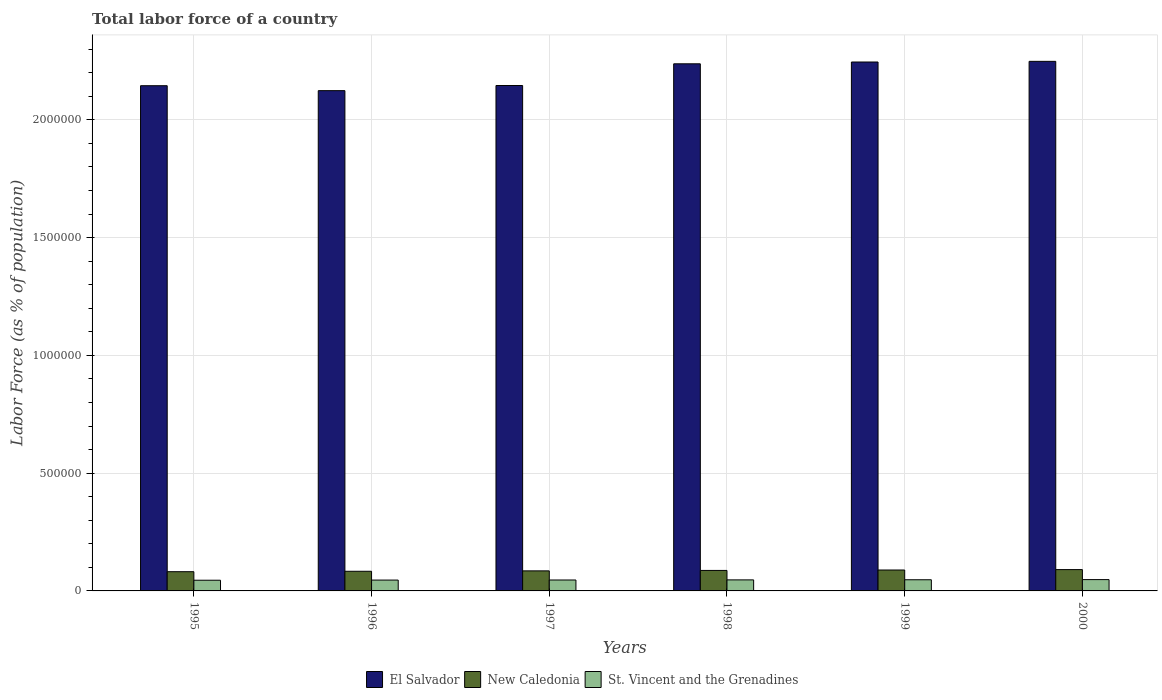How many different coloured bars are there?
Provide a succinct answer. 3. Are the number of bars on each tick of the X-axis equal?
Your answer should be compact. Yes. How many bars are there on the 4th tick from the right?
Your answer should be very brief. 3. What is the percentage of labor force in New Caledonia in 1996?
Your response must be concise. 8.34e+04. Across all years, what is the maximum percentage of labor force in New Caledonia?
Your answer should be very brief. 9.05e+04. Across all years, what is the minimum percentage of labor force in St. Vincent and the Grenadines?
Give a very brief answer. 4.54e+04. In which year was the percentage of labor force in El Salvador maximum?
Your answer should be compact. 2000. What is the total percentage of labor force in New Caledonia in the graph?
Your answer should be very brief. 5.16e+05. What is the difference between the percentage of labor force in El Salvador in 1995 and that in 1997?
Offer a very short reply. -845. What is the difference between the percentage of labor force in El Salvador in 1998 and the percentage of labor force in New Caledonia in 1995?
Your answer should be very brief. 2.16e+06. What is the average percentage of labor force in St. Vincent and the Grenadines per year?
Offer a very short reply. 4.67e+04. In the year 1998, what is the difference between the percentage of labor force in New Caledonia and percentage of labor force in St. Vincent and the Grenadines?
Offer a very short reply. 4.01e+04. In how many years, is the percentage of labor force in New Caledonia greater than 2200000 %?
Your response must be concise. 0. What is the ratio of the percentage of labor force in New Caledonia in 1995 to that in 1999?
Your response must be concise. 0.92. Is the percentage of labor force in El Salvador in 1997 less than that in 1999?
Give a very brief answer. Yes. Is the difference between the percentage of labor force in New Caledonia in 1995 and 1998 greater than the difference between the percentage of labor force in St. Vincent and the Grenadines in 1995 and 1998?
Give a very brief answer. No. What is the difference between the highest and the second highest percentage of labor force in El Salvador?
Your answer should be compact. 2773. What is the difference between the highest and the lowest percentage of labor force in New Caledonia?
Offer a very short reply. 8890. What does the 3rd bar from the left in 1995 represents?
Your answer should be compact. St. Vincent and the Grenadines. What does the 2nd bar from the right in 1996 represents?
Make the answer very short. New Caledonia. Are all the bars in the graph horizontal?
Make the answer very short. No. How many years are there in the graph?
Your response must be concise. 6. What is the difference between two consecutive major ticks on the Y-axis?
Provide a short and direct response. 5.00e+05. How many legend labels are there?
Your response must be concise. 3. How are the legend labels stacked?
Your answer should be very brief. Horizontal. What is the title of the graph?
Your answer should be very brief. Total labor force of a country. What is the label or title of the X-axis?
Provide a short and direct response. Years. What is the label or title of the Y-axis?
Offer a terse response. Labor Force (as % of population). What is the Labor Force (as % of population) of El Salvador in 1995?
Your response must be concise. 2.14e+06. What is the Labor Force (as % of population) in New Caledonia in 1995?
Keep it short and to the point. 8.16e+04. What is the Labor Force (as % of population) in St. Vincent and the Grenadines in 1995?
Provide a succinct answer. 4.54e+04. What is the Labor Force (as % of population) of El Salvador in 1996?
Your response must be concise. 2.12e+06. What is the Labor Force (as % of population) in New Caledonia in 1996?
Ensure brevity in your answer.  8.34e+04. What is the Labor Force (as % of population) in St. Vincent and the Grenadines in 1996?
Make the answer very short. 4.61e+04. What is the Labor Force (as % of population) in El Salvador in 1997?
Offer a terse response. 2.15e+06. What is the Labor Force (as % of population) in New Caledonia in 1997?
Give a very brief answer. 8.51e+04. What is the Labor Force (as % of population) of St. Vincent and the Grenadines in 1997?
Provide a succinct answer. 4.64e+04. What is the Labor Force (as % of population) in El Salvador in 1998?
Ensure brevity in your answer.  2.24e+06. What is the Labor Force (as % of population) of New Caledonia in 1998?
Keep it short and to the point. 8.70e+04. What is the Labor Force (as % of population) in St. Vincent and the Grenadines in 1998?
Make the answer very short. 4.69e+04. What is the Labor Force (as % of population) of El Salvador in 1999?
Make the answer very short. 2.25e+06. What is the Labor Force (as % of population) in New Caledonia in 1999?
Make the answer very short. 8.88e+04. What is the Labor Force (as % of population) in St. Vincent and the Grenadines in 1999?
Ensure brevity in your answer.  4.74e+04. What is the Labor Force (as % of population) of El Salvador in 2000?
Ensure brevity in your answer.  2.25e+06. What is the Labor Force (as % of population) in New Caledonia in 2000?
Offer a terse response. 9.05e+04. What is the Labor Force (as % of population) of St. Vincent and the Grenadines in 2000?
Offer a terse response. 4.81e+04. Across all years, what is the maximum Labor Force (as % of population) of El Salvador?
Your answer should be very brief. 2.25e+06. Across all years, what is the maximum Labor Force (as % of population) in New Caledonia?
Make the answer very short. 9.05e+04. Across all years, what is the maximum Labor Force (as % of population) of St. Vincent and the Grenadines?
Offer a terse response. 4.81e+04. Across all years, what is the minimum Labor Force (as % of population) of El Salvador?
Offer a very short reply. 2.12e+06. Across all years, what is the minimum Labor Force (as % of population) of New Caledonia?
Provide a succinct answer. 8.16e+04. Across all years, what is the minimum Labor Force (as % of population) of St. Vincent and the Grenadines?
Your response must be concise. 4.54e+04. What is the total Labor Force (as % of population) of El Salvador in the graph?
Offer a terse response. 1.31e+07. What is the total Labor Force (as % of population) of New Caledonia in the graph?
Provide a short and direct response. 5.16e+05. What is the total Labor Force (as % of population) in St. Vincent and the Grenadines in the graph?
Offer a terse response. 2.80e+05. What is the difference between the Labor Force (as % of population) in El Salvador in 1995 and that in 1996?
Offer a terse response. 2.10e+04. What is the difference between the Labor Force (as % of population) of New Caledonia in 1995 and that in 1996?
Your response must be concise. -1788. What is the difference between the Labor Force (as % of population) in St. Vincent and the Grenadines in 1995 and that in 1996?
Your answer should be very brief. -701. What is the difference between the Labor Force (as % of population) in El Salvador in 1995 and that in 1997?
Your response must be concise. -845. What is the difference between the Labor Force (as % of population) of New Caledonia in 1995 and that in 1997?
Offer a very short reply. -3479. What is the difference between the Labor Force (as % of population) of St. Vincent and the Grenadines in 1995 and that in 1997?
Offer a very short reply. -1035. What is the difference between the Labor Force (as % of population) in El Salvador in 1995 and that in 1998?
Offer a terse response. -9.30e+04. What is the difference between the Labor Force (as % of population) of New Caledonia in 1995 and that in 1998?
Your response must be concise. -5379. What is the difference between the Labor Force (as % of population) of St. Vincent and the Grenadines in 1995 and that in 1998?
Offer a terse response. -1502. What is the difference between the Labor Force (as % of population) in El Salvador in 1995 and that in 1999?
Give a very brief answer. -1.01e+05. What is the difference between the Labor Force (as % of population) in New Caledonia in 1995 and that in 1999?
Your answer should be very brief. -7140. What is the difference between the Labor Force (as % of population) in St. Vincent and the Grenadines in 1995 and that in 1999?
Your answer should be very brief. -2028. What is the difference between the Labor Force (as % of population) of El Salvador in 1995 and that in 2000?
Give a very brief answer. -1.03e+05. What is the difference between the Labor Force (as % of population) in New Caledonia in 1995 and that in 2000?
Your answer should be very brief. -8890. What is the difference between the Labor Force (as % of population) of St. Vincent and the Grenadines in 1995 and that in 2000?
Provide a succinct answer. -2700. What is the difference between the Labor Force (as % of population) of El Salvador in 1996 and that in 1997?
Provide a succinct answer. -2.18e+04. What is the difference between the Labor Force (as % of population) in New Caledonia in 1996 and that in 1997?
Offer a very short reply. -1691. What is the difference between the Labor Force (as % of population) in St. Vincent and the Grenadines in 1996 and that in 1997?
Your answer should be compact. -334. What is the difference between the Labor Force (as % of population) in El Salvador in 1996 and that in 1998?
Provide a succinct answer. -1.14e+05. What is the difference between the Labor Force (as % of population) of New Caledonia in 1996 and that in 1998?
Your answer should be very brief. -3591. What is the difference between the Labor Force (as % of population) in St. Vincent and the Grenadines in 1996 and that in 1998?
Offer a very short reply. -801. What is the difference between the Labor Force (as % of population) in El Salvador in 1996 and that in 1999?
Your answer should be compact. -1.22e+05. What is the difference between the Labor Force (as % of population) of New Caledonia in 1996 and that in 1999?
Offer a terse response. -5352. What is the difference between the Labor Force (as % of population) of St. Vincent and the Grenadines in 1996 and that in 1999?
Provide a short and direct response. -1327. What is the difference between the Labor Force (as % of population) in El Salvador in 1996 and that in 2000?
Make the answer very short. -1.24e+05. What is the difference between the Labor Force (as % of population) of New Caledonia in 1996 and that in 2000?
Keep it short and to the point. -7102. What is the difference between the Labor Force (as % of population) of St. Vincent and the Grenadines in 1996 and that in 2000?
Keep it short and to the point. -1999. What is the difference between the Labor Force (as % of population) of El Salvador in 1997 and that in 1998?
Provide a short and direct response. -9.22e+04. What is the difference between the Labor Force (as % of population) of New Caledonia in 1997 and that in 1998?
Ensure brevity in your answer.  -1900. What is the difference between the Labor Force (as % of population) in St. Vincent and the Grenadines in 1997 and that in 1998?
Provide a short and direct response. -467. What is the difference between the Labor Force (as % of population) of El Salvador in 1997 and that in 1999?
Keep it short and to the point. -9.98e+04. What is the difference between the Labor Force (as % of population) of New Caledonia in 1997 and that in 1999?
Provide a short and direct response. -3661. What is the difference between the Labor Force (as % of population) in St. Vincent and the Grenadines in 1997 and that in 1999?
Your answer should be compact. -993. What is the difference between the Labor Force (as % of population) in El Salvador in 1997 and that in 2000?
Offer a very short reply. -1.03e+05. What is the difference between the Labor Force (as % of population) of New Caledonia in 1997 and that in 2000?
Provide a succinct answer. -5411. What is the difference between the Labor Force (as % of population) in St. Vincent and the Grenadines in 1997 and that in 2000?
Keep it short and to the point. -1665. What is the difference between the Labor Force (as % of population) of El Salvador in 1998 and that in 1999?
Offer a terse response. -7639. What is the difference between the Labor Force (as % of population) of New Caledonia in 1998 and that in 1999?
Provide a short and direct response. -1761. What is the difference between the Labor Force (as % of population) of St. Vincent and the Grenadines in 1998 and that in 1999?
Your answer should be very brief. -526. What is the difference between the Labor Force (as % of population) of El Salvador in 1998 and that in 2000?
Keep it short and to the point. -1.04e+04. What is the difference between the Labor Force (as % of population) of New Caledonia in 1998 and that in 2000?
Your answer should be very brief. -3511. What is the difference between the Labor Force (as % of population) of St. Vincent and the Grenadines in 1998 and that in 2000?
Give a very brief answer. -1198. What is the difference between the Labor Force (as % of population) of El Salvador in 1999 and that in 2000?
Offer a terse response. -2773. What is the difference between the Labor Force (as % of population) in New Caledonia in 1999 and that in 2000?
Ensure brevity in your answer.  -1750. What is the difference between the Labor Force (as % of population) in St. Vincent and the Grenadines in 1999 and that in 2000?
Keep it short and to the point. -672. What is the difference between the Labor Force (as % of population) of El Salvador in 1995 and the Labor Force (as % of population) of New Caledonia in 1996?
Your answer should be very brief. 2.06e+06. What is the difference between the Labor Force (as % of population) in El Salvador in 1995 and the Labor Force (as % of population) in St. Vincent and the Grenadines in 1996?
Offer a terse response. 2.10e+06. What is the difference between the Labor Force (as % of population) in New Caledonia in 1995 and the Labor Force (as % of population) in St. Vincent and the Grenadines in 1996?
Offer a very short reply. 3.56e+04. What is the difference between the Labor Force (as % of population) of El Salvador in 1995 and the Labor Force (as % of population) of New Caledonia in 1997?
Give a very brief answer. 2.06e+06. What is the difference between the Labor Force (as % of population) of El Salvador in 1995 and the Labor Force (as % of population) of St. Vincent and the Grenadines in 1997?
Make the answer very short. 2.10e+06. What is the difference between the Labor Force (as % of population) of New Caledonia in 1995 and the Labor Force (as % of population) of St. Vincent and the Grenadines in 1997?
Make the answer very short. 3.52e+04. What is the difference between the Labor Force (as % of population) of El Salvador in 1995 and the Labor Force (as % of population) of New Caledonia in 1998?
Offer a very short reply. 2.06e+06. What is the difference between the Labor Force (as % of population) of El Salvador in 1995 and the Labor Force (as % of population) of St. Vincent and the Grenadines in 1998?
Offer a very short reply. 2.10e+06. What is the difference between the Labor Force (as % of population) of New Caledonia in 1995 and the Labor Force (as % of population) of St. Vincent and the Grenadines in 1998?
Make the answer very short. 3.48e+04. What is the difference between the Labor Force (as % of population) in El Salvador in 1995 and the Labor Force (as % of population) in New Caledonia in 1999?
Ensure brevity in your answer.  2.06e+06. What is the difference between the Labor Force (as % of population) of El Salvador in 1995 and the Labor Force (as % of population) of St. Vincent and the Grenadines in 1999?
Your answer should be very brief. 2.10e+06. What is the difference between the Labor Force (as % of population) of New Caledonia in 1995 and the Labor Force (as % of population) of St. Vincent and the Grenadines in 1999?
Offer a very short reply. 3.42e+04. What is the difference between the Labor Force (as % of population) of El Salvador in 1995 and the Labor Force (as % of population) of New Caledonia in 2000?
Ensure brevity in your answer.  2.05e+06. What is the difference between the Labor Force (as % of population) in El Salvador in 1995 and the Labor Force (as % of population) in St. Vincent and the Grenadines in 2000?
Offer a very short reply. 2.10e+06. What is the difference between the Labor Force (as % of population) of New Caledonia in 1995 and the Labor Force (as % of population) of St. Vincent and the Grenadines in 2000?
Keep it short and to the point. 3.36e+04. What is the difference between the Labor Force (as % of population) of El Salvador in 1996 and the Labor Force (as % of population) of New Caledonia in 1997?
Provide a succinct answer. 2.04e+06. What is the difference between the Labor Force (as % of population) of El Salvador in 1996 and the Labor Force (as % of population) of St. Vincent and the Grenadines in 1997?
Provide a succinct answer. 2.08e+06. What is the difference between the Labor Force (as % of population) in New Caledonia in 1996 and the Labor Force (as % of population) in St. Vincent and the Grenadines in 1997?
Give a very brief answer. 3.70e+04. What is the difference between the Labor Force (as % of population) in El Salvador in 1996 and the Labor Force (as % of population) in New Caledonia in 1998?
Your response must be concise. 2.04e+06. What is the difference between the Labor Force (as % of population) of El Salvador in 1996 and the Labor Force (as % of population) of St. Vincent and the Grenadines in 1998?
Ensure brevity in your answer.  2.08e+06. What is the difference between the Labor Force (as % of population) of New Caledonia in 1996 and the Labor Force (as % of population) of St. Vincent and the Grenadines in 1998?
Your answer should be very brief. 3.65e+04. What is the difference between the Labor Force (as % of population) in El Salvador in 1996 and the Labor Force (as % of population) in New Caledonia in 1999?
Provide a short and direct response. 2.03e+06. What is the difference between the Labor Force (as % of population) of El Salvador in 1996 and the Labor Force (as % of population) of St. Vincent and the Grenadines in 1999?
Your answer should be very brief. 2.08e+06. What is the difference between the Labor Force (as % of population) in New Caledonia in 1996 and the Labor Force (as % of population) in St. Vincent and the Grenadines in 1999?
Ensure brevity in your answer.  3.60e+04. What is the difference between the Labor Force (as % of population) of El Salvador in 1996 and the Labor Force (as % of population) of New Caledonia in 2000?
Your answer should be very brief. 2.03e+06. What is the difference between the Labor Force (as % of population) of El Salvador in 1996 and the Labor Force (as % of population) of St. Vincent and the Grenadines in 2000?
Provide a short and direct response. 2.08e+06. What is the difference between the Labor Force (as % of population) in New Caledonia in 1996 and the Labor Force (as % of population) in St. Vincent and the Grenadines in 2000?
Keep it short and to the point. 3.53e+04. What is the difference between the Labor Force (as % of population) of El Salvador in 1997 and the Labor Force (as % of population) of New Caledonia in 1998?
Provide a succinct answer. 2.06e+06. What is the difference between the Labor Force (as % of population) of El Salvador in 1997 and the Labor Force (as % of population) of St. Vincent and the Grenadines in 1998?
Ensure brevity in your answer.  2.10e+06. What is the difference between the Labor Force (as % of population) in New Caledonia in 1997 and the Labor Force (as % of population) in St. Vincent and the Grenadines in 1998?
Offer a very short reply. 3.82e+04. What is the difference between the Labor Force (as % of population) in El Salvador in 1997 and the Labor Force (as % of population) in New Caledonia in 1999?
Provide a short and direct response. 2.06e+06. What is the difference between the Labor Force (as % of population) in El Salvador in 1997 and the Labor Force (as % of population) in St. Vincent and the Grenadines in 1999?
Provide a succinct answer. 2.10e+06. What is the difference between the Labor Force (as % of population) in New Caledonia in 1997 and the Labor Force (as % of population) in St. Vincent and the Grenadines in 1999?
Provide a succinct answer. 3.77e+04. What is the difference between the Labor Force (as % of population) of El Salvador in 1997 and the Labor Force (as % of population) of New Caledonia in 2000?
Offer a terse response. 2.05e+06. What is the difference between the Labor Force (as % of population) of El Salvador in 1997 and the Labor Force (as % of population) of St. Vincent and the Grenadines in 2000?
Ensure brevity in your answer.  2.10e+06. What is the difference between the Labor Force (as % of population) of New Caledonia in 1997 and the Labor Force (as % of population) of St. Vincent and the Grenadines in 2000?
Offer a very short reply. 3.70e+04. What is the difference between the Labor Force (as % of population) of El Salvador in 1998 and the Labor Force (as % of population) of New Caledonia in 1999?
Offer a terse response. 2.15e+06. What is the difference between the Labor Force (as % of population) in El Salvador in 1998 and the Labor Force (as % of population) in St. Vincent and the Grenadines in 1999?
Keep it short and to the point. 2.19e+06. What is the difference between the Labor Force (as % of population) in New Caledonia in 1998 and the Labor Force (as % of population) in St. Vincent and the Grenadines in 1999?
Make the answer very short. 3.96e+04. What is the difference between the Labor Force (as % of population) of El Salvador in 1998 and the Labor Force (as % of population) of New Caledonia in 2000?
Keep it short and to the point. 2.15e+06. What is the difference between the Labor Force (as % of population) in El Salvador in 1998 and the Labor Force (as % of population) in St. Vincent and the Grenadines in 2000?
Provide a short and direct response. 2.19e+06. What is the difference between the Labor Force (as % of population) in New Caledonia in 1998 and the Labor Force (as % of population) in St. Vincent and the Grenadines in 2000?
Your response must be concise. 3.89e+04. What is the difference between the Labor Force (as % of population) of El Salvador in 1999 and the Labor Force (as % of population) of New Caledonia in 2000?
Provide a succinct answer. 2.15e+06. What is the difference between the Labor Force (as % of population) of El Salvador in 1999 and the Labor Force (as % of population) of St. Vincent and the Grenadines in 2000?
Ensure brevity in your answer.  2.20e+06. What is the difference between the Labor Force (as % of population) of New Caledonia in 1999 and the Labor Force (as % of population) of St. Vincent and the Grenadines in 2000?
Make the answer very short. 4.07e+04. What is the average Labor Force (as % of population) in El Salvador per year?
Offer a very short reply. 2.19e+06. What is the average Labor Force (as % of population) in New Caledonia per year?
Provide a succinct answer. 8.61e+04. What is the average Labor Force (as % of population) of St. Vincent and the Grenadines per year?
Provide a succinct answer. 4.67e+04. In the year 1995, what is the difference between the Labor Force (as % of population) in El Salvador and Labor Force (as % of population) in New Caledonia?
Provide a short and direct response. 2.06e+06. In the year 1995, what is the difference between the Labor Force (as % of population) of El Salvador and Labor Force (as % of population) of St. Vincent and the Grenadines?
Your answer should be very brief. 2.10e+06. In the year 1995, what is the difference between the Labor Force (as % of population) of New Caledonia and Labor Force (as % of population) of St. Vincent and the Grenadines?
Keep it short and to the point. 3.63e+04. In the year 1996, what is the difference between the Labor Force (as % of population) in El Salvador and Labor Force (as % of population) in New Caledonia?
Your response must be concise. 2.04e+06. In the year 1996, what is the difference between the Labor Force (as % of population) in El Salvador and Labor Force (as % of population) in St. Vincent and the Grenadines?
Keep it short and to the point. 2.08e+06. In the year 1996, what is the difference between the Labor Force (as % of population) of New Caledonia and Labor Force (as % of population) of St. Vincent and the Grenadines?
Provide a succinct answer. 3.73e+04. In the year 1997, what is the difference between the Labor Force (as % of population) of El Salvador and Labor Force (as % of population) of New Caledonia?
Offer a very short reply. 2.06e+06. In the year 1997, what is the difference between the Labor Force (as % of population) of El Salvador and Labor Force (as % of population) of St. Vincent and the Grenadines?
Provide a short and direct response. 2.10e+06. In the year 1997, what is the difference between the Labor Force (as % of population) of New Caledonia and Labor Force (as % of population) of St. Vincent and the Grenadines?
Offer a terse response. 3.87e+04. In the year 1998, what is the difference between the Labor Force (as % of population) of El Salvador and Labor Force (as % of population) of New Caledonia?
Your response must be concise. 2.15e+06. In the year 1998, what is the difference between the Labor Force (as % of population) in El Salvador and Labor Force (as % of population) in St. Vincent and the Grenadines?
Provide a short and direct response. 2.19e+06. In the year 1998, what is the difference between the Labor Force (as % of population) in New Caledonia and Labor Force (as % of population) in St. Vincent and the Grenadines?
Your response must be concise. 4.01e+04. In the year 1999, what is the difference between the Labor Force (as % of population) in El Salvador and Labor Force (as % of population) in New Caledonia?
Offer a terse response. 2.16e+06. In the year 1999, what is the difference between the Labor Force (as % of population) of El Salvador and Labor Force (as % of population) of St. Vincent and the Grenadines?
Offer a terse response. 2.20e+06. In the year 1999, what is the difference between the Labor Force (as % of population) of New Caledonia and Labor Force (as % of population) of St. Vincent and the Grenadines?
Offer a terse response. 4.14e+04. In the year 2000, what is the difference between the Labor Force (as % of population) in El Salvador and Labor Force (as % of population) in New Caledonia?
Your answer should be very brief. 2.16e+06. In the year 2000, what is the difference between the Labor Force (as % of population) in El Salvador and Labor Force (as % of population) in St. Vincent and the Grenadines?
Make the answer very short. 2.20e+06. In the year 2000, what is the difference between the Labor Force (as % of population) of New Caledonia and Labor Force (as % of population) of St. Vincent and the Grenadines?
Make the answer very short. 4.24e+04. What is the ratio of the Labor Force (as % of population) in El Salvador in 1995 to that in 1996?
Give a very brief answer. 1.01. What is the ratio of the Labor Force (as % of population) of New Caledonia in 1995 to that in 1996?
Keep it short and to the point. 0.98. What is the ratio of the Labor Force (as % of population) in St. Vincent and the Grenadines in 1995 to that in 1996?
Your answer should be compact. 0.98. What is the ratio of the Labor Force (as % of population) in El Salvador in 1995 to that in 1997?
Offer a very short reply. 1. What is the ratio of the Labor Force (as % of population) in New Caledonia in 1995 to that in 1997?
Make the answer very short. 0.96. What is the ratio of the Labor Force (as % of population) in St. Vincent and the Grenadines in 1995 to that in 1997?
Make the answer very short. 0.98. What is the ratio of the Labor Force (as % of population) in El Salvador in 1995 to that in 1998?
Offer a terse response. 0.96. What is the ratio of the Labor Force (as % of population) of New Caledonia in 1995 to that in 1998?
Offer a terse response. 0.94. What is the ratio of the Labor Force (as % of population) in El Salvador in 1995 to that in 1999?
Your answer should be compact. 0.96. What is the ratio of the Labor Force (as % of population) of New Caledonia in 1995 to that in 1999?
Your answer should be very brief. 0.92. What is the ratio of the Labor Force (as % of population) in St. Vincent and the Grenadines in 1995 to that in 1999?
Your response must be concise. 0.96. What is the ratio of the Labor Force (as % of population) in El Salvador in 1995 to that in 2000?
Ensure brevity in your answer.  0.95. What is the ratio of the Labor Force (as % of population) of New Caledonia in 1995 to that in 2000?
Make the answer very short. 0.9. What is the ratio of the Labor Force (as % of population) of St. Vincent and the Grenadines in 1995 to that in 2000?
Your answer should be very brief. 0.94. What is the ratio of the Labor Force (as % of population) of New Caledonia in 1996 to that in 1997?
Offer a very short reply. 0.98. What is the ratio of the Labor Force (as % of population) of St. Vincent and the Grenadines in 1996 to that in 1997?
Your answer should be compact. 0.99. What is the ratio of the Labor Force (as % of population) in El Salvador in 1996 to that in 1998?
Your response must be concise. 0.95. What is the ratio of the Labor Force (as % of population) of New Caledonia in 1996 to that in 1998?
Make the answer very short. 0.96. What is the ratio of the Labor Force (as % of population) in St. Vincent and the Grenadines in 1996 to that in 1998?
Your answer should be very brief. 0.98. What is the ratio of the Labor Force (as % of population) in El Salvador in 1996 to that in 1999?
Provide a short and direct response. 0.95. What is the ratio of the Labor Force (as % of population) of New Caledonia in 1996 to that in 1999?
Give a very brief answer. 0.94. What is the ratio of the Labor Force (as % of population) in St. Vincent and the Grenadines in 1996 to that in 1999?
Your answer should be very brief. 0.97. What is the ratio of the Labor Force (as % of population) of El Salvador in 1996 to that in 2000?
Offer a terse response. 0.94. What is the ratio of the Labor Force (as % of population) of New Caledonia in 1996 to that in 2000?
Ensure brevity in your answer.  0.92. What is the ratio of the Labor Force (as % of population) in St. Vincent and the Grenadines in 1996 to that in 2000?
Offer a terse response. 0.96. What is the ratio of the Labor Force (as % of population) of El Salvador in 1997 to that in 1998?
Provide a short and direct response. 0.96. What is the ratio of the Labor Force (as % of population) of New Caledonia in 1997 to that in 1998?
Your response must be concise. 0.98. What is the ratio of the Labor Force (as % of population) in St. Vincent and the Grenadines in 1997 to that in 1998?
Ensure brevity in your answer.  0.99. What is the ratio of the Labor Force (as % of population) in El Salvador in 1997 to that in 1999?
Offer a terse response. 0.96. What is the ratio of the Labor Force (as % of population) in New Caledonia in 1997 to that in 1999?
Provide a short and direct response. 0.96. What is the ratio of the Labor Force (as % of population) of St. Vincent and the Grenadines in 1997 to that in 1999?
Make the answer very short. 0.98. What is the ratio of the Labor Force (as % of population) in El Salvador in 1997 to that in 2000?
Your answer should be compact. 0.95. What is the ratio of the Labor Force (as % of population) of New Caledonia in 1997 to that in 2000?
Provide a short and direct response. 0.94. What is the ratio of the Labor Force (as % of population) of St. Vincent and the Grenadines in 1997 to that in 2000?
Offer a very short reply. 0.97. What is the ratio of the Labor Force (as % of population) of New Caledonia in 1998 to that in 1999?
Your answer should be compact. 0.98. What is the ratio of the Labor Force (as % of population) of St. Vincent and the Grenadines in 1998 to that in 1999?
Provide a succinct answer. 0.99. What is the ratio of the Labor Force (as % of population) of El Salvador in 1998 to that in 2000?
Offer a very short reply. 1. What is the ratio of the Labor Force (as % of population) in New Caledonia in 1998 to that in 2000?
Make the answer very short. 0.96. What is the ratio of the Labor Force (as % of population) of St. Vincent and the Grenadines in 1998 to that in 2000?
Provide a succinct answer. 0.98. What is the ratio of the Labor Force (as % of population) in El Salvador in 1999 to that in 2000?
Your response must be concise. 1. What is the ratio of the Labor Force (as % of population) in New Caledonia in 1999 to that in 2000?
Your response must be concise. 0.98. What is the ratio of the Labor Force (as % of population) in St. Vincent and the Grenadines in 1999 to that in 2000?
Your response must be concise. 0.99. What is the difference between the highest and the second highest Labor Force (as % of population) in El Salvador?
Keep it short and to the point. 2773. What is the difference between the highest and the second highest Labor Force (as % of population) in New Caledonia?
Your response must be concise. 1750. What is the difference between the highest and the second highest Labor Force (as % of population) of St. Vincent and the Grenadines?
Provide a short and direct response. 672. What is the difference between the highest and the lowest Labor Force (as % of population) of El Salvador?
Make the answer very short. 1.24e+05. What is the difference between the highest and the lowest Labor Force (as % of population) of New Caledonia?
Make the answer very short. 8890. What is the difference between the highest and the lowest Labor Force (as % of population) in St. Vincent and the Grenadines?
Provide a short and direct response. 2700. 